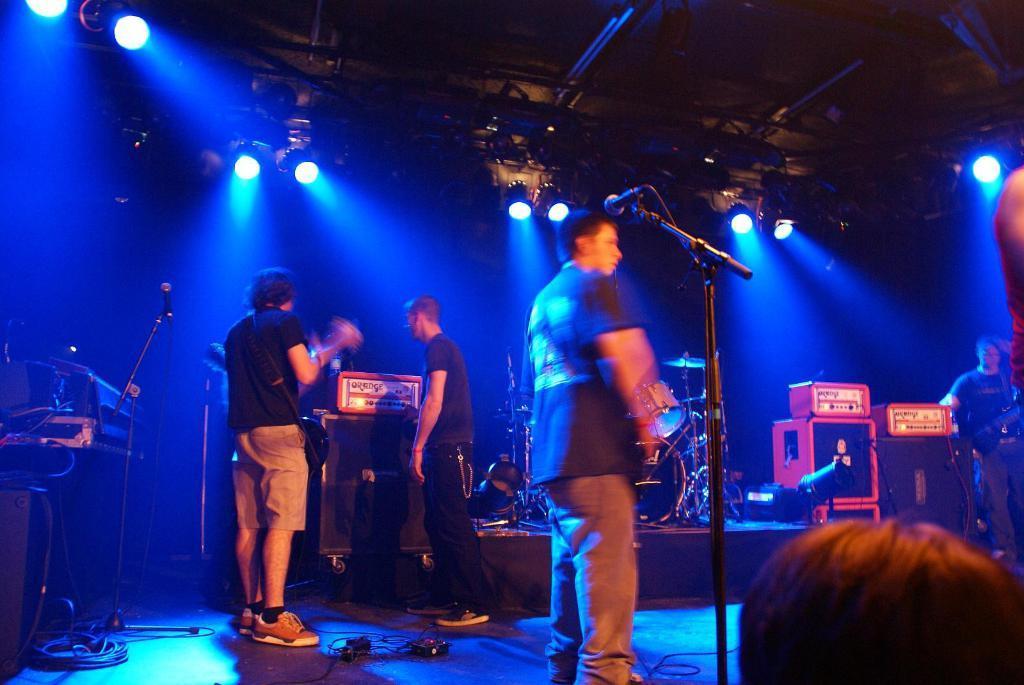How would you summarize this image in a sentence or two? In the picture i can see some group of persons standing and playing musical instruments there are some sound boxes, microphones and top of the picture there are some lights, roof. 